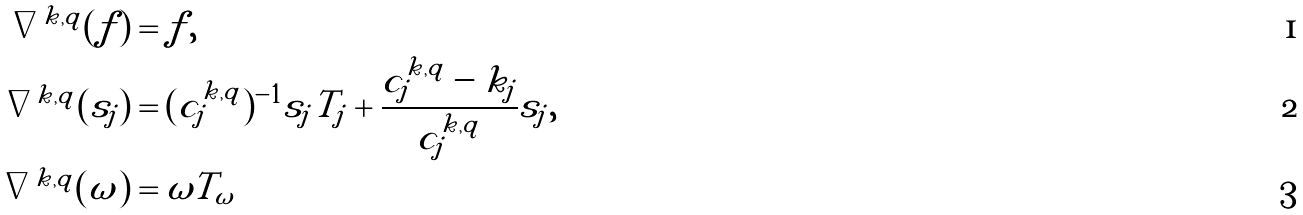<formula> <loc_0><loc_0><loc_500><loc_500>\nabla ^ { k , q } ( f ) & = f , \\ \nabla ^ { k , q } ( s _ { j } ) & = ( c _ { j } ^ { k , q } ) ^ { - 1 } s _ { j } T _ { j } + \frac { c _ { j } ^ { k , q } - k _ { j } } { c _ { j } ^ { k , q } } s _ { j } , \\ \nabla ^ { k , q } ( \omega ) & = \omega T _ { \omega }</formula> 